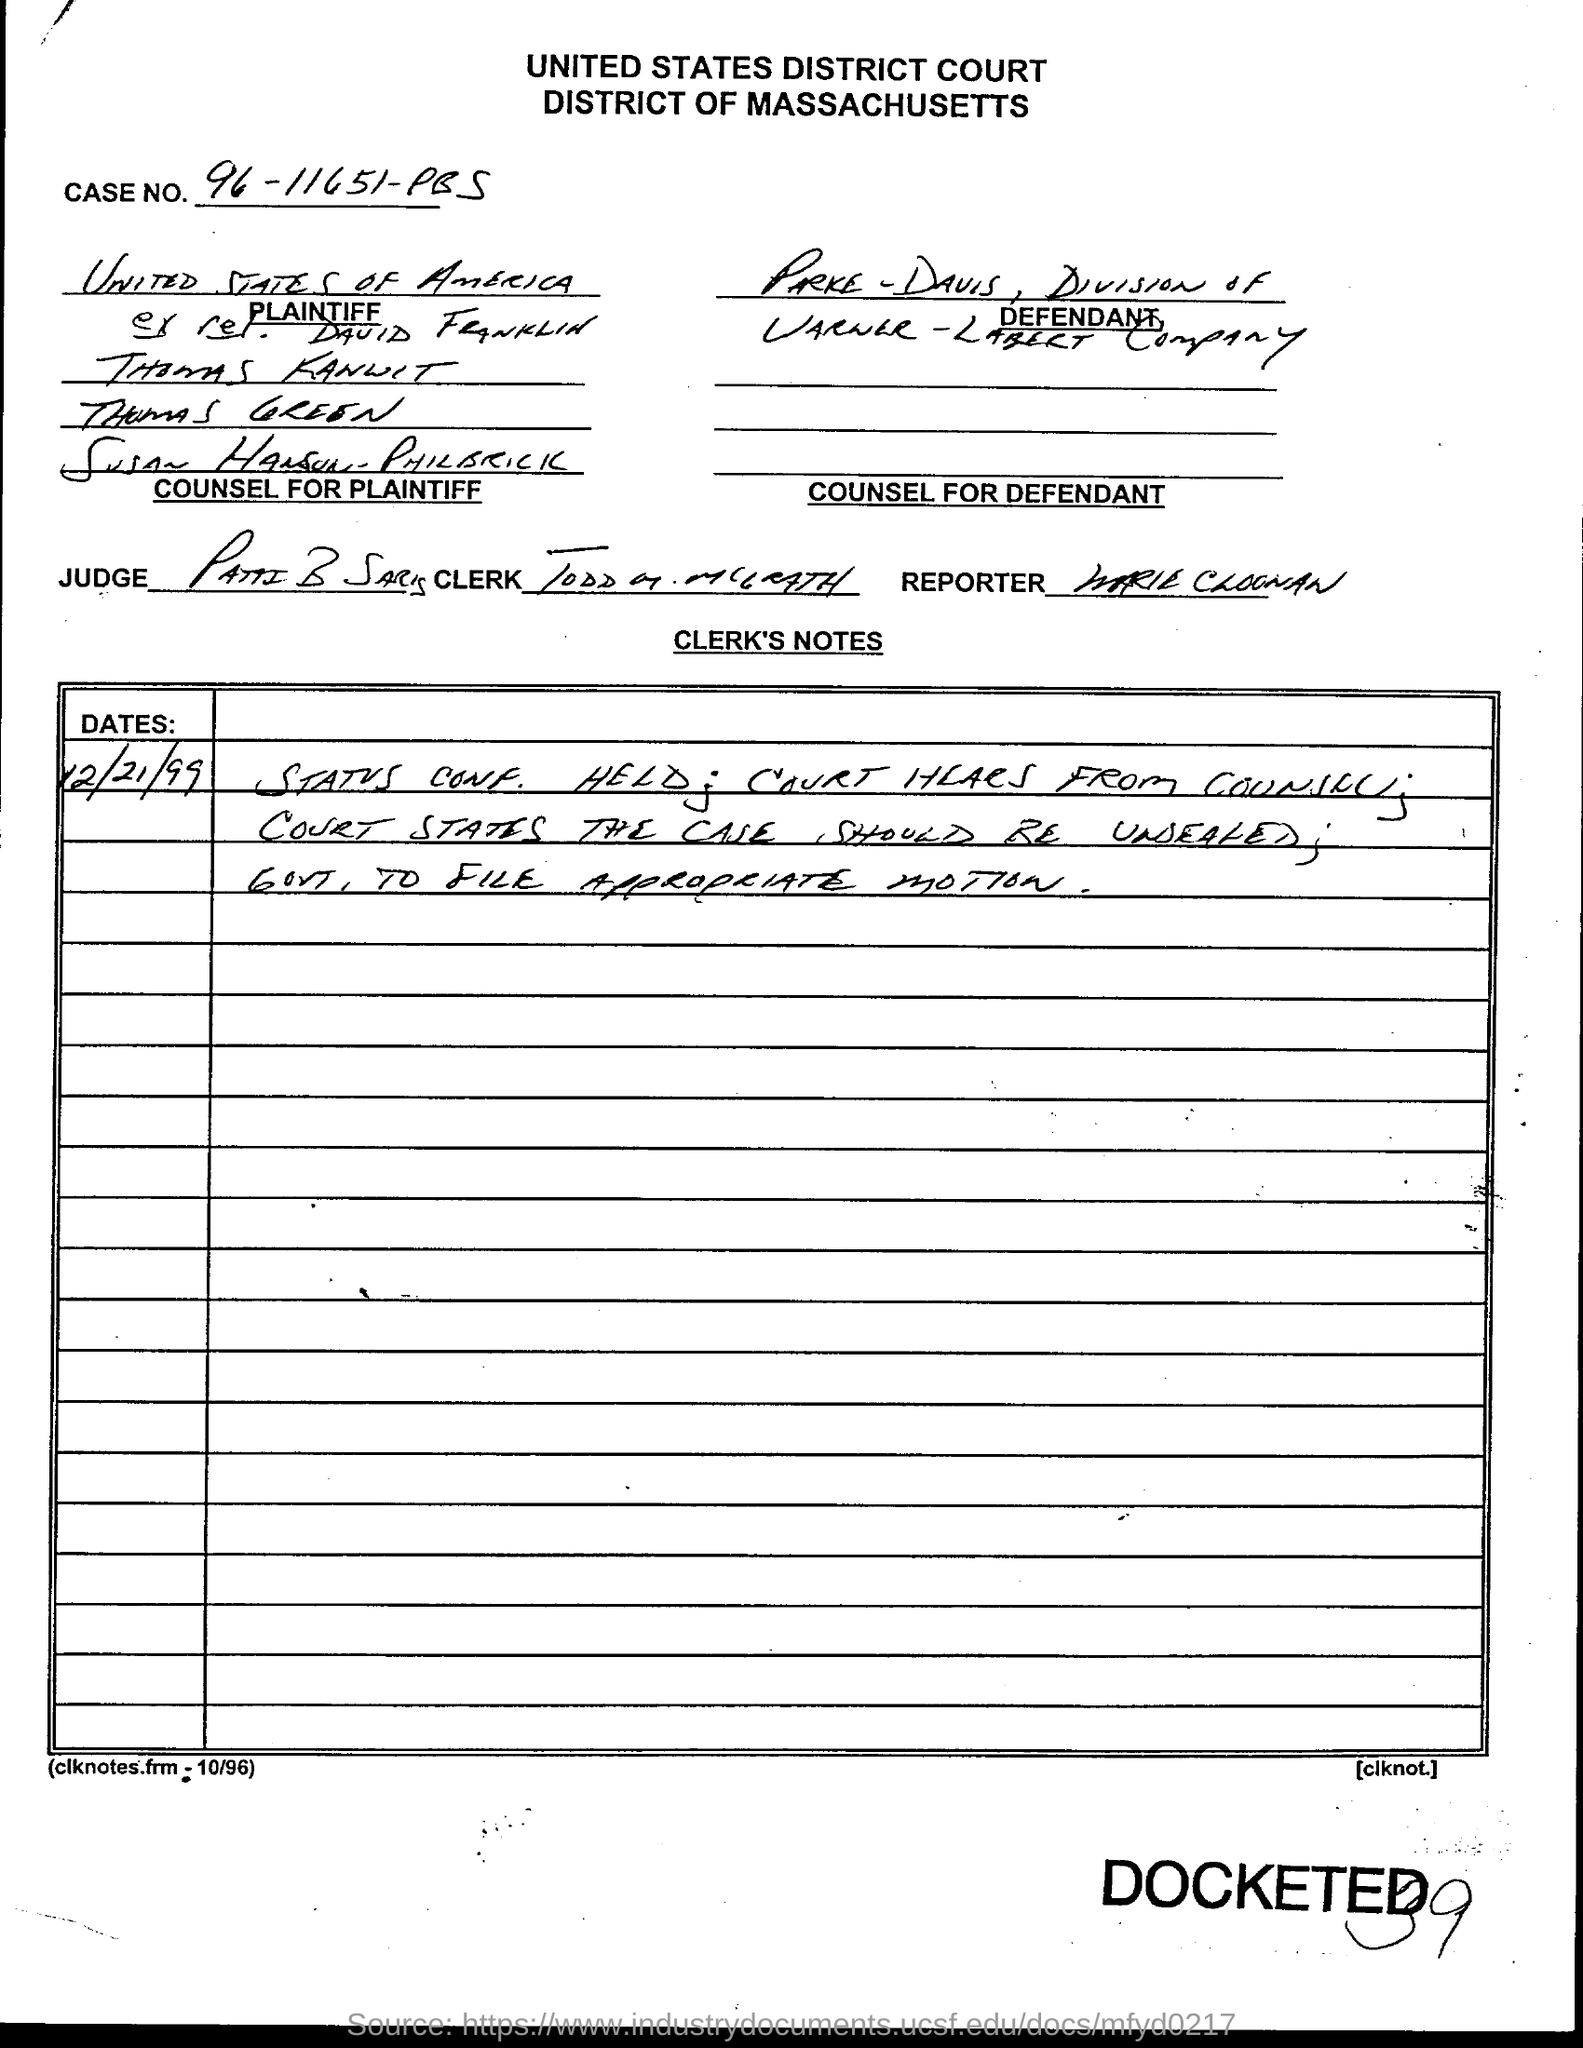Mention a couple of crucial points in this snapshot. The case number is 96-11651-PBS...," the declaration reads. 